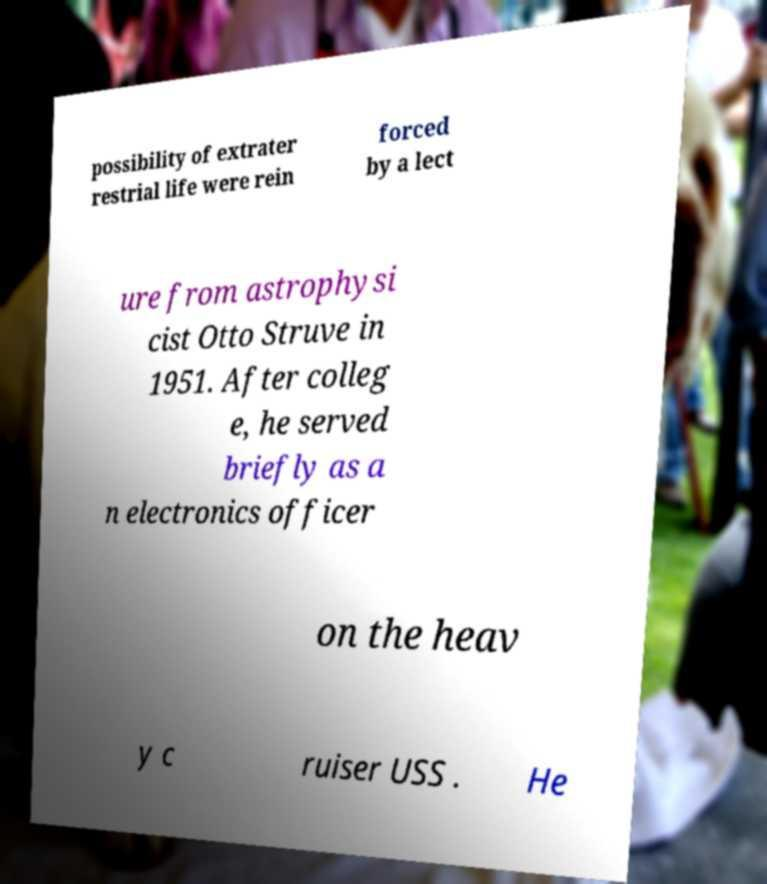For documentation purposes, I need the text within this image transcribed. Could you provide that? possibility of extrater restrial life were rein forced by a lect ure from astrophysi cist Otto Struve in 1951. After colleg e, he served briefly as a n electronics officer on the heav y c ruiser USS . He 